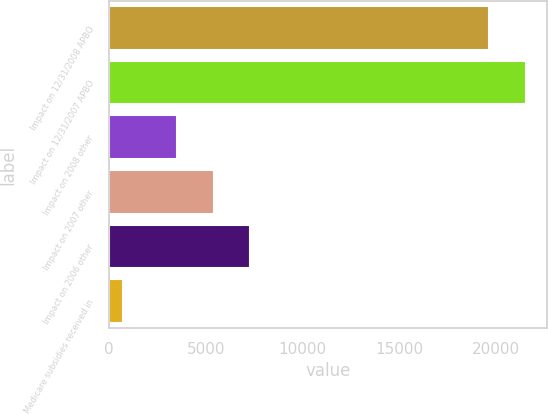Convert chart. <chart><loc_0><loc_0><loc_500><loc_500><bar_chart><fcel>Impact on 12/31/2008 APBO<fcel>Impact on 12/31/2007 APBO<fcel>Impact on 2008 other<fcel>Impact on 2007 other<fcel>Impact on 2006 other<fcel>Medicare subsidies received in<nl><fcel>19650<fcel>21544.8<fcel>3502<fcel>5396.8<fcel>7291.6<fcel>714<nl></chart> 